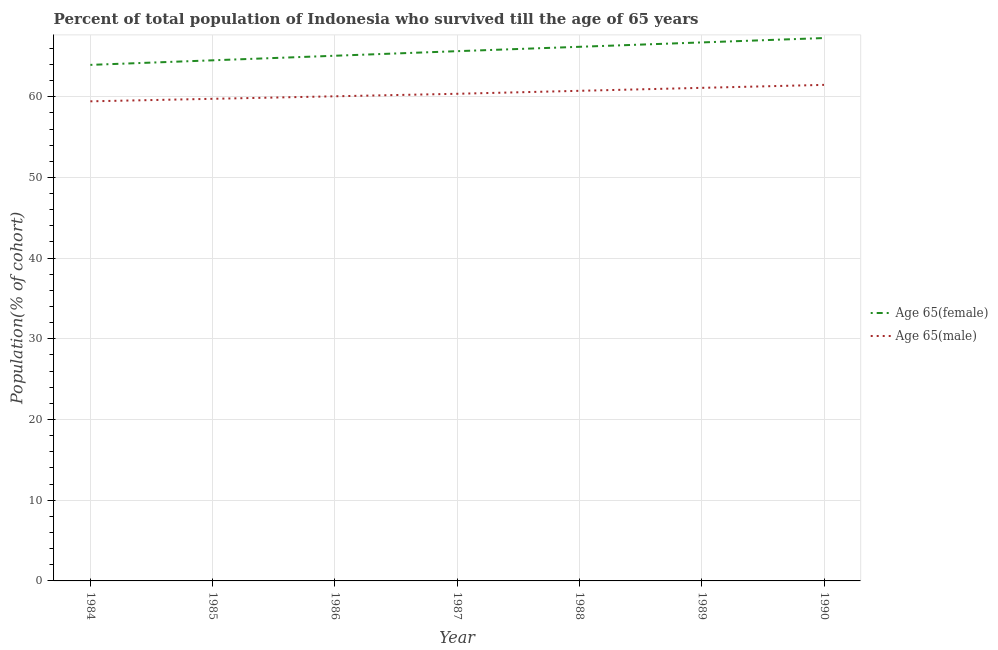How many different coloured lines are there?
Ensure brevity in your answer.  2. What is the percentage of male population who survived till age of 65 in 1984?
Give a very brief answer. 59.43. Across all years, what is the maximum percentage of female population who survived till age of 65?
Your response must be concise. 67.27. Across all years, what is the minimum percentage of female population who survived till age of 65?
Offer a terse response. 63.95. In which year was the percentage of male population who survived till age of 65 minimum?
Give a very brief answer. 1984. What is the total percentage of female population who survived till age of 65 in the graph?
Offer a terse response. 459.39. What is the difference between the percentage of female population who survived till age of 65 in 1987 and that in 1988?
Make the answer very short. -0.54. What is the difference between the percentage of female population who survived till age of 65 in 1990 and the percentage of male population who survived till age of 65 in 1984?
Offer a terse response. 7.84. What is the average percentage of male population who survived till age of 65 per year?
Offer a terse response. 60.42. In the year 1989, what is the difference between the percentage of female population who survived till age of 65 and percentage of male population who survived till age of 65?
Provide a short and direct response. 5.63. In how many years, is the percentage of female population who survived till age of 65 greater than 44 %?
Offer a very short reply. 7. What is the ratio of the percentage of female population who survived till age of 65 in 1989 to that in 1990?
Keep it short and to the point. 0.99. What is the difference between the highest and the second highest percentage of male population who survived till age of 65?
Ensure brevity in your answer.  0.37. What is the difference between the highest and the lowest percentage of female population who survived till age of 65?
Your answer should be very brief. 3.33. In how many years, is the percentage of female population who survived till age of 65 greater than the average percentage of female population who survived till age of 65 taken over all years?
Your response must be concise. 4. Is the sum of the percentage of male population who survived till age of 65 in 1986 and 1989 greater than the maximum percentage of female population who survived till age of 65 across all years?
Keep it short and to the point. Yes. Is the percentage of female population who survived till age of 65 strictly greater than the percentage of male population who survived till age of 65 over the years?
Your response must be concise. Yes. How many lines are there?
Keep it short and to the point. 2. Does the graph contain any zero values?
Your answer should be compact. No. What is the title of the graph?
Offer a very short reply. Percent of total population of Indonesia who survived till the age of 65 years. What is the label or title of the Y-axis?
Offer a very short reply. Population(% of cohort). What is the Population(% of cohort) in Age 65(female) in 1984?
Your response must be concise. 63.95. What is the Population(% of cohort) of Age 65(male) in 1984?
Provide a short and direct response. 59.43. What is the Population(% of cohort) in Age 65(female) in 1985?
Give a very brief answer. 64.51. What is the Population(% of cohort) of Age 65(male) in 1985?
Make the answer very short. 59.74. What is the Population(% of cohort) of Age 65(female) in 1986?
Provide a succinct answer. 65.08. What is the Population(% of cohort) of Age 65(male) in 1986?
Offer a terse response. 60.06. What is the Population(% of cohort) of Age 65(female) in 1987?
Ensure brevity in your answer.  65.65. What is the Population(% of cohort) of Age 65(male) in 1987?
Offer a terse response. 60.37. What is the Population(% of cohort) in Age 65(female) in 1988?
Your answer should be very brief. 66.19. What is the Population(% of cohort) in Age 65(male) in 1988?
Provide a succinct answer. 60.74. What is the Population(% of cohort) of Age 65(female) in 1989?
Your answer should be compact. 66.73. What is the Population(% of cohort) in Age 65(male) in 1989?
Provide a succinct answer. 61.1. What is the Population(% of cohort) of Age 65(female) in 1990?
Provide a succinct answer. 67.27. What is the Population(% of cohort) of Age 65(male) in 1990?
Your answer should be compact. 61.47. Across all years, what is the maximum Population(% of cohort) of Age 65(female)?
Your answer should be very brief. 67.27. Across all years, what is the maximum Population(% of cohort) of Age 65(male)?
Give a very brief answer. 61.47. Across all years, what is the minimum Population(% of cohort) of Age 65(female)?
Provide a succinct answer. 63.95. Across all years, what is the minimum Population(% of cohort) in Age 65(male)?
Your answer should be very brief. 59.43. What is the total Population(% of cohort) of Age 65(female) in the graph?
Offer a terse response. 459.39. What is the total Population(% of cohort) of Age 65(male) in the graph?
Offer a very short reply. 422.91. What is the difference between the Population(% of cohort) of Age 65(female) in 1984 and that in 1985?
Ensure brevity in your answer.  -0.57. What is the difference between the Population(% of cohort) of Age 65(male) in 1984 and that in 1985?
Make the answer very short. -0.31. What is the difference between the Population(% of cohort) of Age 65(female) in 1984 and that in 1986?
Provide a succinct answer. -1.13. What is the difference between the Population(% of cohort) of Age 65(male) in 1984 and that in 1986?
Make the answer very short. -0.62. What is the difference between the Population(% of cohort) in Age 65(female) in 1984 and that in 1987?
Make the answer very short. -1.7. What is the difference between the Population(% of cohort) in Age 65(male) in 1984 and that in 1987?
Offer a terse response. -0.93. What is the difference between the Population(% of cohort) of Age 65(female) in 1984 and that in 1988?
Provide a succinct answer. -2.24. What is the difference between the Population(% of cohort) of Age 65(male) in 1984 and that in 1988?
Your answer should be compact. -1.3. What is the difference between the Population(% of cohort) in Age 65(female) in 1984 and that in 1989?
Your answer should be very brief. -2.78. What is the difference between the Population(% of cohort) of Age 65(male) in 1984 and that in 1989?
Give a very brief answer. -1.67. What is the difference between the Population(% of cohort) of Age 65(female) in 1984 and that in 1990?
Keep it short and to the point. -3.33. What is the difference between the Population(% of cohort) of Age 65(male) in 1984 and that in 1990?
Provide a short and direct response. -2.04. What is the difference between the Population(% of cohort) in Age 65(female) in 1985 and that in 1986?
Offer a terse response. -0.57. What is the difference between the Population(% of cohort) of Age 65(male) in 1985 and that in 1986?
Give a very brief answer. -0.31. What is the difference between the Population(% of cohort) of Age 65(female) in 1985 and that in 1987?
Give a very brief answer. -1.13. What is the difference between the Population(% of cohort) of Age 65(male) in 1985 and that in 1987?
Offer a terse response. -0.62. What is the difference between the Population(% of cohort) of Age 65(female) in 1985 and that in 1988?
Offer a terse response. -1.67. What is the difference between the Population(% of cohort) of Age 65(male) in 1985 and that in 1988?
Keep it short and to the point. -0.99. What is the difference between the Population(% of cohort) in Age 65(female) in 1985 and that in 1989?
Ensure brevity in your answer.  -2.22. What is the difference between the Population(% of cohort) in Age 65(male) in 1985 and that in 1989?
Provide a short and direct response. -1.36. What is the difference between the Population(% of cohort) in Age 65(female) in 1985 and that in 1990?
Give a very brief answer. -2.76. What is the difference between the Population(% of cohort) in Age 65(male) in 1985 and that in 1990?
Your response must be concise. -1.73. What is the difference between the Population(% of cohort) in Age 65(female) in 1986 and that in 1987?
Keep it short and to the point. -0.57. What is the difference between the Population(% of cohort) in Age 65(male) in 1986 and that in 1987?
Offer a very short reply. -0.31. What is the difference between the Population(% of cohort) in Age 65(female) in 1986 and that in 1988?
Ensure brevity in your answer.  -1.11. What is the difference between the Population(% of cohort) of Age 65(male) in 1986 and that in 1988?
Ensure brevity in your answer.  -0.68. What is the difference between the Population(% of cohort) in Age 65(female) in 1986 and that in 1989?
Ensure brevity in your answer.  -1.65. What is the difference between the Population(% of cohort) in Age 65(male) in 1986 and that in 1989?
Provide a succinct answer. -1.05. What is the difference between the Population(% of cohort) of Age 65(female) in 1986 and that in 1990?
Your answer should be very brief. -2.19. What is the difference between the Population(% of cohort) in Age 65(male) in 1986 and that in 1990?
Ensure brevity in your answer.  -1.41. What is the difference between the Population(% of cohort) in Age 65(female) in 1987 and that in 1988?
Provide a succinct answer. -0.54. What is the difference between the Population(% of cohort) of Age 65(male) in 1987 and that in 1988?
Ensure brevity in your answer.  -0.37. What is the difference between the Population(% of cohort) in Age 65(female) in 1987 and that in 1989?
Make the answer very short. -1.09. What is the difference between the Population(% of cohort) in Age 65(male) in 1987 and that in 1989?
Offer a terse response. -0.74. What is the difference between the Population(% of cohort) of Age 65(female) in 1987 and that in 1990?
Your answer should be very brief. -1.63. What is the difference between the Population(% of cohort) in Age 65(male) in 1987 and that in 1990?
Keep it short and to the point. -1.1. What is the difference between the Population(% of cohort) of Age 65(female) in 1988 and that in 1989?
Provide a succinct answer. -0.54. What is the difference between the Population(% of cohort) of Age 65(male) in 1988 and that in 1989?
Make the answer very short. -0.37. What is the difference between the Population(% of cohort) of Age 65(female) in 1988 and that in 1990?
Your response must be concise. -1.09. What is the difference between the Population(% of cohort) in Age 65(male) in 1988 and that in 1990?
Offer a very short reply. -0.74. What is the difference between the Population(% of cohort) in Age 65(female) in 1989 and that in 1990?
Your answer should be very brief. -0.54. What is the difference between the Population(% of cohort) in Age 65(male) in 1989 and that in 1990?
Offer a very short reply. -0.37. What is the difference between the Population(% of cohort) in Age 65(female) in 1984 and the Population(% of cohort) in Age 65(male) in 1985?
Ensure brevity in your answer.  4.2. What is the difference between the Population(% of cohort) of Age 65(female) in 1984 and the Population(% of cohort) of Age 65(male) in 1986?
Provide a short and direct response. 3.89. What is the difference between the Population(% of cohort) of Age 65(female) in 1984 and the Population(% of cohort) of Age 65(male) in 1987?
Your answer should be very brief. 3.58. What is the difference between the Population(% of cohort) in Age 65(female) in 1984 and the Population(% of cohort) in Age 65(male) in 1988?
Your response must be concise. 3.21. What is the difference between the Population(% of cohort) in Age 65(female) in 1984 and the Population(% of cohort) in Age 65(male) in 1989?
Ensure brevity in your answer.  2.85. What is the difference between the Population(% of cohort) in Age 65(female) in 1984 and the Population(% of cohort) in Age 65(male) in 1990?
Your answer should be compact. 2.48. What is the difference between the Population(% of cohort) of Age 65(female) in 1985 and the Population(% of cohort) of Age 65(male) in 1986?
Offer a terse response. 4.46. What is the difference between the Population(% of cohort) of Age 65(female) in 1985 and the Population(% of cohort) of Age 65(male) in 1987?
Keep it short and to the point. 4.15. What is the difference between the Population(% of cohort) of Age 65(female) in 1985 and the Population(% of cohort) of Age 65(male) in 1988?
Your response must be concise. 3.78. What is the difference between the Population(% of cohort) of Age 65(female) in 1985 and the Population(% of cohort) of Age 65(male) in 1989?
Provide a short and direct response. 3.41. What is the difference between the Population(% of cohort) in Age 65(female) in 1985 and the Population(% of cohort) in Age 65(male) in 1990?
Your answer should be compact. 3.04. What is the difference between the Population(% of cohort) in Age 65(female) in 1986 and the Population(% of cohort) in Age 65(male) in 1987?
Offer a very short reply. 4.71. What is the difference between the Population(% of cohort) of Age 65(female) in 1986 and the Population(% of cohort) of Age 65(male) in 1988?
Your response must be concise. 4.35. What is the difference between the Population(% of cohort) in Age 65(female) in 1986 and the Population(% of cohort) in Age 65(male) in 1989?
Keep it short and to the point. 3.98. What is the difference between the Population(% of cohort) in Age 65(female) in 1986 and the Population(% of cohort) in Age 65(male) in 1990?
Offer a very short reply. 3.61. What is the difference between the Population(% of cohort) in Age 65(female) in 1987 and the Population(% of cohort) in Age 65(male) in 1988?
Keep it short and to the point. 4.91. What is the difference between the Population(% of cohort) in Age 65(female) in 1987 and the Population(% of cohort) in Age 65(male) in 1989?
Ensure brevity in your answer.  4.54. What is the difference between the Population(% of cohort) of Age 65(female) in 1987 and the Population(% of cohort) of Age 65(male) in 1990?
Your answer should be very brief. 4.18. What is the difference between the Population(% of cohort) of Age 65(female) in 1988 and the Population(% of cohort) of Age 65(male) in 1989?
Make the answer very short. 5.09. What is the difference between the Population(% of cohort) in Age 65(female) in 1988 and the Population(% of cohort) in Age 65(male) in 1990?
Offer a very short reply. 4.72. What is the difference between the Population(% of cohort) of Age 65(female) in 1989 and the Population(% of cohort) of Age 65(male) in 1990?
Provide a succinct answer. 5.26. What is the average Population(% of cohort) in Age 65(female) per year?
Offer a very short reply. 65.63. What is the average Population(% of cohort) of Age 65(male) per year?
Give a very brief answer. 60.42. In the year 1984, what is the difference between the Population(% of cohort) in Age 65(female) and Population(% of cohort) in Age 65(male)?
Your answer should be compact. 4.52. In the year 1985, what is the difference between the Population(% of cohort) of Age 65(female) and Population(% of cohort) of Age 65(male)?
Ensure brevity in your answer.  4.77. In the year 1986, what is the difference between the Population(% of cohort) of Age 65(female) and Population(% of cohort) of Age 65(male)?
Give a very brief answer. 5.02. In the year 1987, what is the difference between the Population(% of cohort) of Age 65(female) and Population(% of cohort) of Age 65(male)?
Give a very brief answer. 5.28. In the year 1988, what is the difference between the Population(% of cohort) of Age 65(female) and Population(% of cohort) of Age 65(male)?
Offer a terse response. 5.45. In the year 1989, what is the difference between the Population(% of cohort) in Age 65(female) and Population(% of cohort) in Age 65(male)?
Ensure brevity in your answer.  5.63. In the year 1990, what is the difference between the Population(% of cohort) in Age 65(female) and Population(% of cohort) in Age 65(male)?
Provide a short and direct response. 5.8. What is the ratio of the Population(% of cohort) in Age 65(female) in 1984 to that in 1985?
Ensure brevity in your answer.  0.99. What is the ratio of the Population(% of cohort) in Age 65(female) in 1984 to that in 1986?
Ensure brevity in your answer.  0.98. What is the ratio of the Population(% of cohort) of Age 65(female) in 1984 to that in 1987?
Make the answer very short. 0.97. What is the ratio of the Population(% of cohort) in Age 65(male) in 1984 to that in 1987?
Your answer should be very brief. 0.98. What is the ratio of the Population(% of cohort) in Age 65(female) in 1984 to that in 1988?
Offer a terse response. 0.97. What is the ratio of the Population(% of cohort) of Age 65(male) in 1984 to that in 1988?
Provide a short and direct response. 0.98. What is the ratio of the Population(% of cohort) in Age 65(female) in 1984 to that in 1989?
Your answer should be compact. 0.96. What is the ratio of the Population(% of cohort) of Age 65(male) in 1984 to that in 1989?
Your answer should be very brief. 0.97. What is the ratio of the Population(% of cohort) of Age 65(female) in 1984 to that in 1990?
Provide a succinct answer. 0.95. What is the ratio of the Population(% of cohort) of Age 65(male) in 1984 to that in 1990?
Ensure brevity in your answer.  0.97. What is the ratio of the Population(% of cohort) in Age 65(male) in 1985 to that in 1986?
Ensure brevity in your answer.  0.99. What is the ratio of the Population(% of cohort) of Age 65(female) in 1985 to that in 1987?
Your response must be concise. 0.98. What is the ratio of the Population(% of cohort) in Age 65(female) in 1985 to that in 1988?
Your answer should be very brief. 0.97. What is the ratio of the Population(% of cohort) of Age 65(male) in 1985 to that in 1988?
Your answer should be compact. 0.98. What is the ratio of the Population(% of cohort) of Age 65(female) in 1985 to that in 1989?
Provide a short and direct response. 0.97. What is the ratio of the Population(% of cohort) in Age 65(male) in 1985 to that in 1989?
Offer a very short reply. 0.98. What is the ratio of the Population(% of cohort) of Age 65(male) in 1985 to that in 1990?
Ensure brevity in your answer.  0.97. What is the ratio of the Population(% of cohort) of Age 65(male) in 1986 to that in 1987?
Provide a succinct answer. 0.99. What is the ratio of the Population(% of cohort) in Age 65(female) in 1986 to that in 1988?
Give a very brief answer. 0.98. What is the ratio of the Population(% of cohort) in Age 65(female) in 1986 to that in 1989?
Offer a very short reply. 0.98. What is the ratio of the Population(% of cohort) in Age 65(male) in 1986 to that in 1989?
Keep it short and to the point. 0.98. What is the ratio of the Population(% of cohort) in Age 65(female) in 1986 to that in 1990?
Provide a succinct answer. 0.97. What is the ratio of the Population(% of cohort) of Age 65(male) in 1986 to that in 1990?
Make the answer very short. 0.98. What is the ratio of the Population(% of cohort) of Age 65(female) in 1987 to that in 1988?
Keep it short and to the point. 0.99. What is the ratio of the Population(% of cohort) of Age 65(male) in 1987 to that in 1988?
Give a very brief answer. 0.99. What is the ratio of the Population(% of cohort) of Age 65(female) in 1987 to that in 1989?
Your answer should be very brief. 0.98. What is the ratio of the Population(% of cohort) in Age 65(female) in 1987 to that in 1990?
Make the answer very short. 0.98. What is the ratio of the Population(% of cohort) of Age 65(male) in 1987 to that in 1990?
Provide a short and direct response. 0.98. What is the ratio of the Population(% of cohort) in Age 65(female) in 1988 to that in 1989?
Give a very brief answer. 0.99. What is the ratio of the Population(% of cohort) in Age 65(male) in 1988 to that in 1989?
Make the answer very short. 0.99. What is the ratio of the Population(% of cohort) in Age 65(female) in 1988 to that in 1990?
Provide a short and direct response. 0.98. What is the difference between the highest and the second highest Population(% of cohort) of Age 65(female)?
Provide a short and direct response. 0.54. What is the difference between the highest and the second highest Population(% of cohort) in Age 65(male)?
Ensure brevity in your answer.  0.37. What is the difference between the highest and the lowest Population(% of cohort) in Age 65(female)?
Provide a short and direct response. 3.33. What is the difference between the highest and the lowest Population(% of cohort) of Age 65(male)?
Provide a succinct answer. 2.04. 